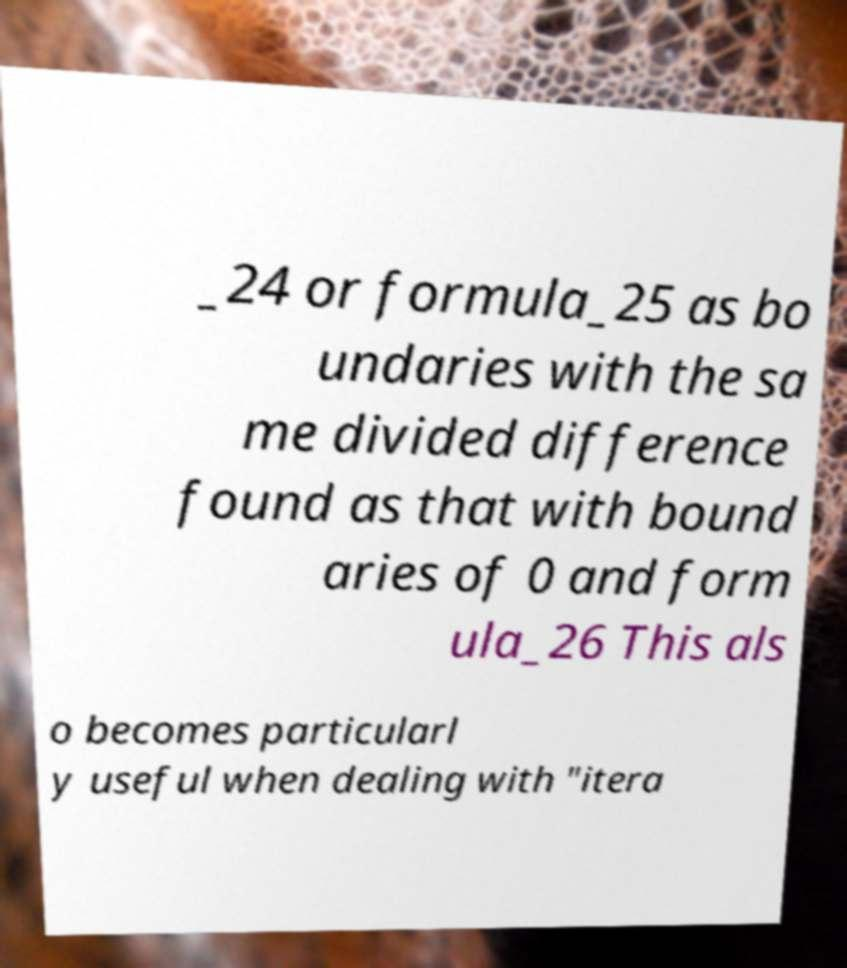Could you extract and type out the text from this image? _24 or formula_25 as bo undaries with the sa me divided difference found as that with bound aries of 0 and form ula_26 This als o becomes particularl y useful when dealing with "itera 